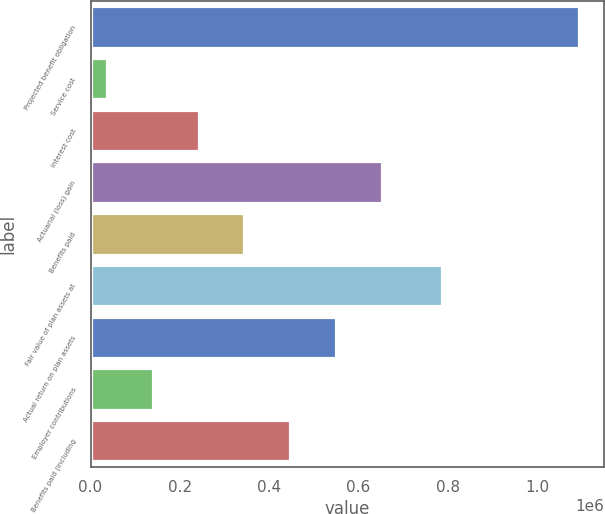Convert chart to OTSL. <chart><loc_0><loc_0><loc_500><loc_500><bar_chart><fcel>Projected benefit obligation<fcel>Service cost<fcel>Interest cost<fcel>Actuarial (loss) gain<fcel>Benefits paid<fcel>Fair value of plan assets at<fcel>Actual return on plan assets<fcel>Employer contributions<fcel>Benefits paid (including<nl><fcel>1.09498e+06<fcel>36609<fcel>242096<fcel>653069<fcel>344839<fcel>786750<fcel>550326<fcel>139352<fcel>447582<nl></chart> 